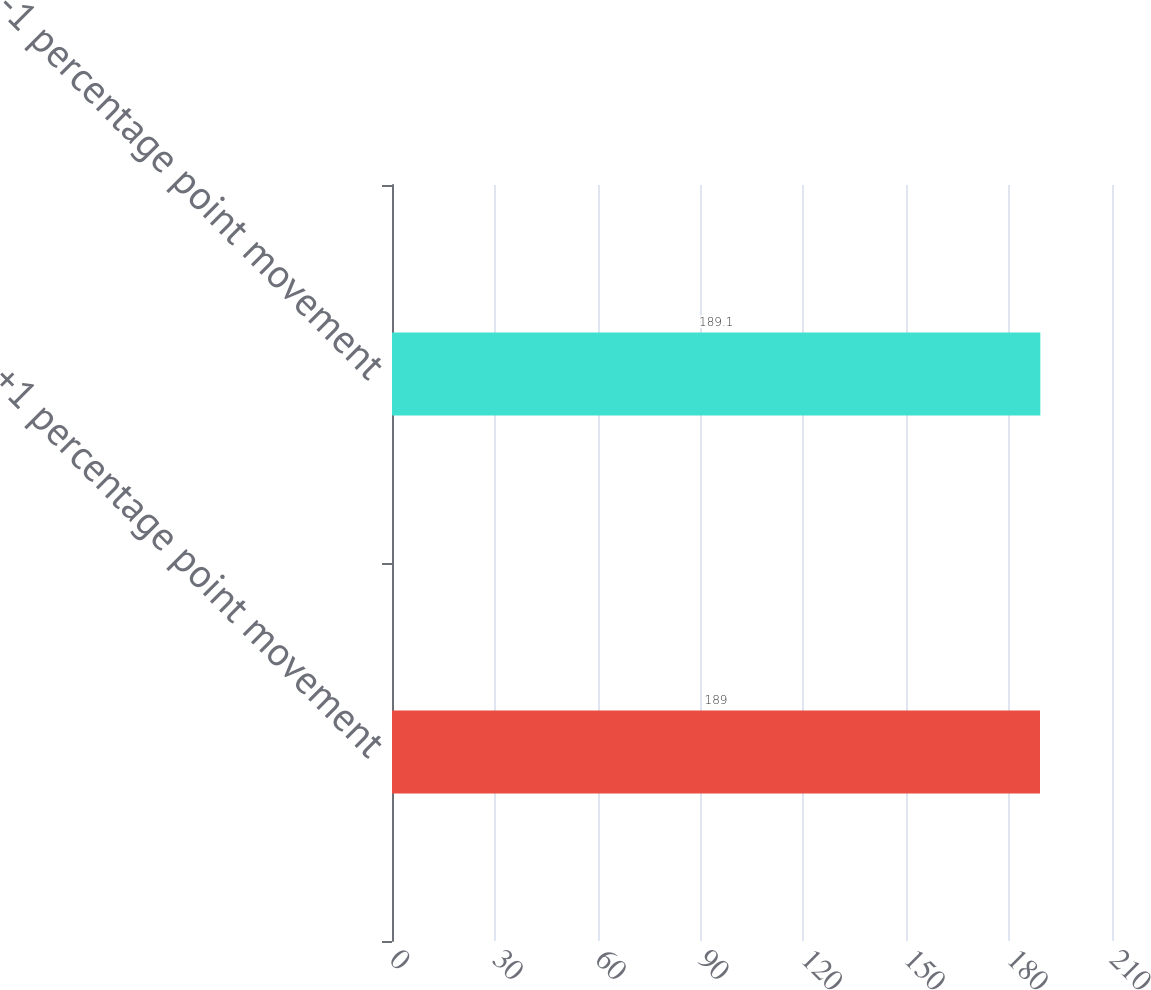Convert chart. <chart><loc_0><loc_0><loc_500><loc_500><bar_chart><fcel>+1 percentage point movement<fcel>-1 percentage point movement<nl><fcel>189<fcel>189.1<nl></chart> 